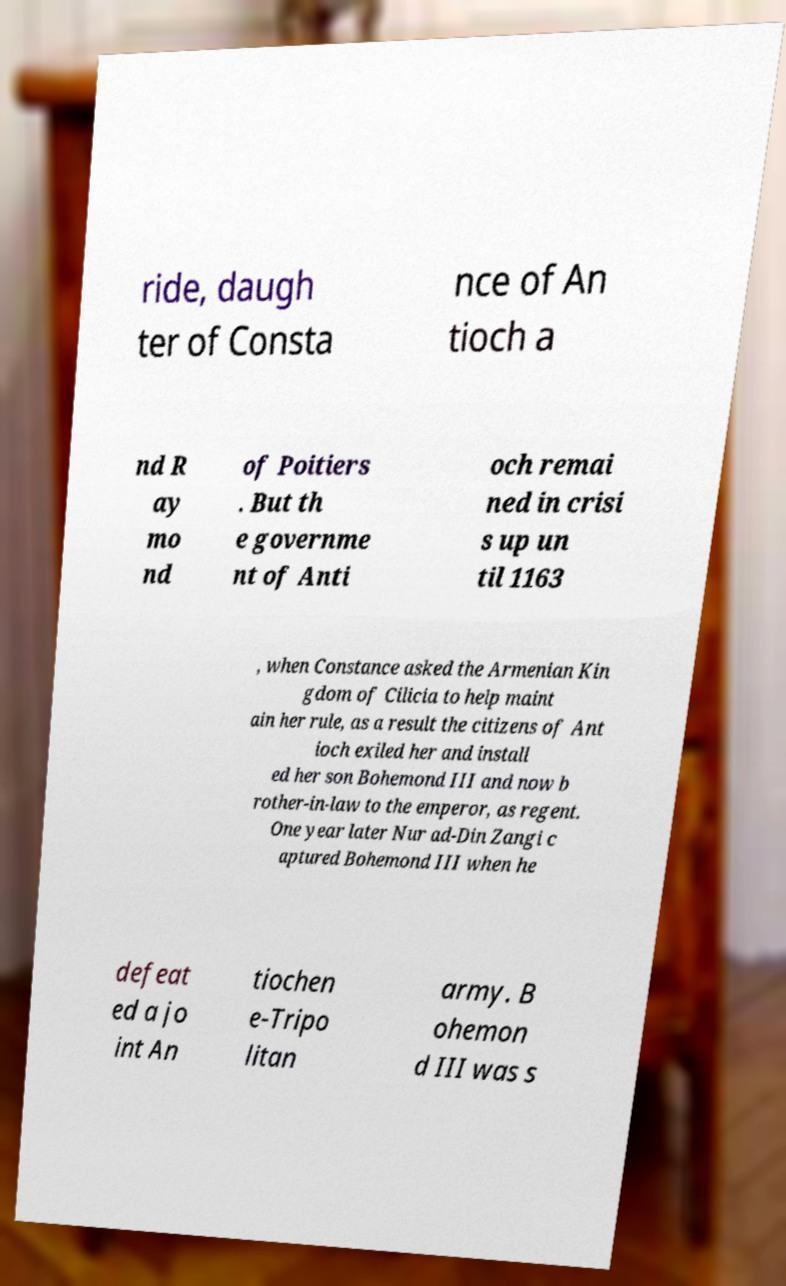Please read and relay the text visible in this image. What does it say? ride, daugh ter of Consta nce of An tioch a nd R ay mo nd of Poitiers . But th e governme nt of Anti och remai ned in crisi s up un til 1163 , when Constance asked the Armenian Kin gdom of Cilicia to help maint ain her rule, as a result the citizens of Ant ioch exiled her and install ed her son Bohemond III and now b rother-in-law to the emperor, as regent. One year later Nur ad-Din Zangi c aptured Bohemond III when he defeat ed a jo int An tiochen e-Tripo litan army. B ohemon d III was s 